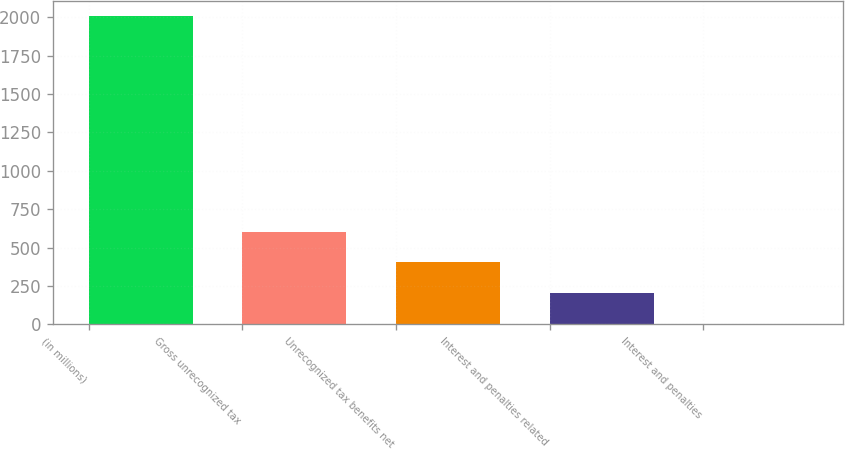Convert chart to OTSL. <chart><loc_0><loc_0><loc_500><loc_500><bar_chart><fcel>(in millions)<fcel>Gross unrecognized tax<fcel>Unrecognized tax benefits net<fcel>Interest and penalties related<fcel>Interest and penalties<nl><fcel>2008<fcel>603.94<fcel>403.36<fcel>202.78<fcel>2.2<nl></chart> 